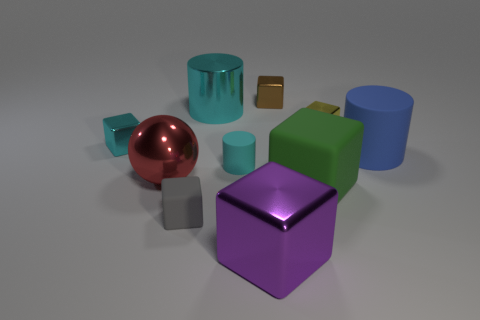There is a large purple object that is made of the same material as the yellow thing; what shape is it?
Your answer should be very brief. Cube. There is a small rubber thing that is left of the big cylinder that is left of the metal cube that is in front of the green rubber block; what is its color?
Offer a terse response. Gray. Are there the same number of red things in front of the large cyan metal cylinder and small brown blocks?
Your answer should be very brief. Yes. There is a shiny cylinder; does it have the same color as the tiny metal cube that is to the left of the gray rubber block?
Provide a short and direct response. Yes. Is there a tiny metallic object to the right of the big cylinder on the left side of the tiny cyan object that is to the right of the tiny gray rubber cube?
Ensure brevity in your answer.  Yes. Are there fewer small cyan objects that are to the right of the blue cylinder than big cyan matte spheres?
Your response must be concise. No. What number of other objects are there of the same shape as the brown thing?
Offer a very short reply. 5. How many things are cylinders that are in front of the small yellow metal block or big metallic objects that are in front of the large green object?
Make the answer very short. 3. There is a metal thing that is both in front of the big blue cylinder and on the left side of the shiny cylinder; how big is it?
Ensure brevity in your answer.  Large. Is the shape of the large object on the right side of the large green rubber cube the same as  the cyan matte thing?
Offer a terse response. Yes. 